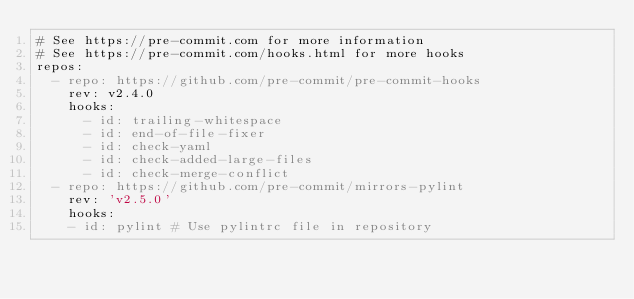<code> <loc_0><loc_0><loc_500><loc_500><_YAML_># See https://pre-commit.com for more information
# See https://pre-commit.com/hooks.html for more hooks
repos:
  - repo: https://github.com/pre-commit/pre-commit-hooks
    rev: v2.4.0
    hooks:
      - id: trailing-whitespace
      - id: end-of-file-fixer
      - id: check-yaml
      - id: check-added-large-files
      - id: check-merge-conflict
  - repo: https://github.com/pre-commit/mirrors-pylint
    rev: 'v2.5.0'
    hooks:
    - id: pylint # Use pylintrc file in repository</code> 